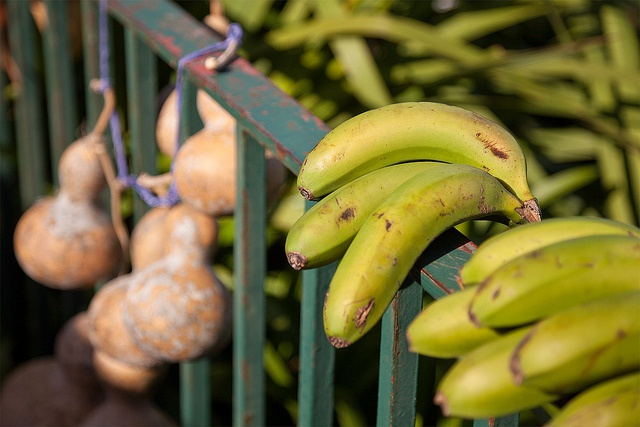Describe the objects in this image and their specific colors. I can see banana in black, olive, and khaki tones, banana in black, olive, gold, and khaki tones, banana in black, khaki, olive, and tan tones, and banana in black, olive, and khaki tones in this image. 